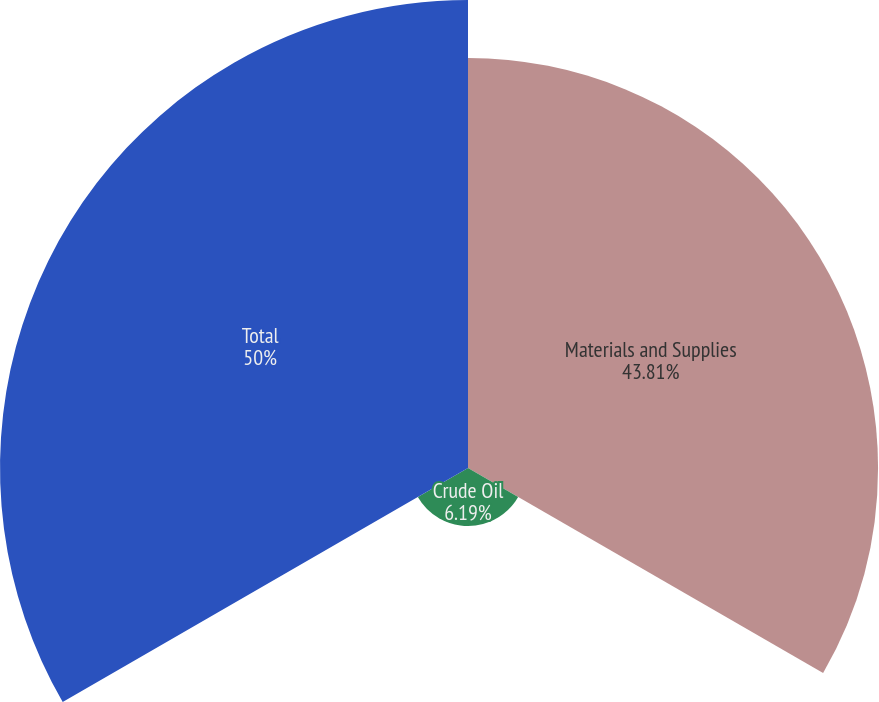Convert chart to OTSL. <chart><loc_0><loc_0><loc_500><loc_500><pie_chart><fcel>Materials and Supplies<fcel>Crude Oil<fcel>Total<nl><fcel>43.81%<fcel>6.19%<fcel>50.0%<nl></chart> 